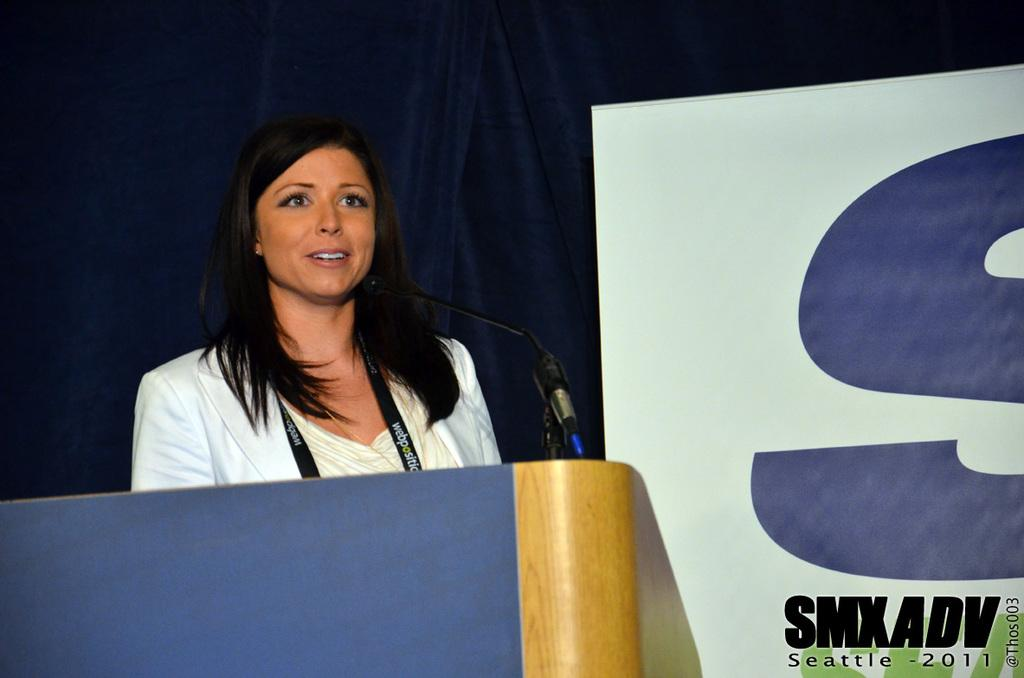Who is the main subject in the image? There is a lady in the image. What is the lady wearing? The lady is wearing a tag. What is in front of the lady? There is a stand with a mic in front of the lady. What can be seen in the background of the image? There is a curtain in the background of the image. What is written on the board in the image? There is a board with something written in the image. What type of paint is being used for the dinner in the image? There is no paint or dinner present in the image. How does the lady plan to change the color of the board in the image? There is no indication in the image that the lady plans to change the color of the board. 